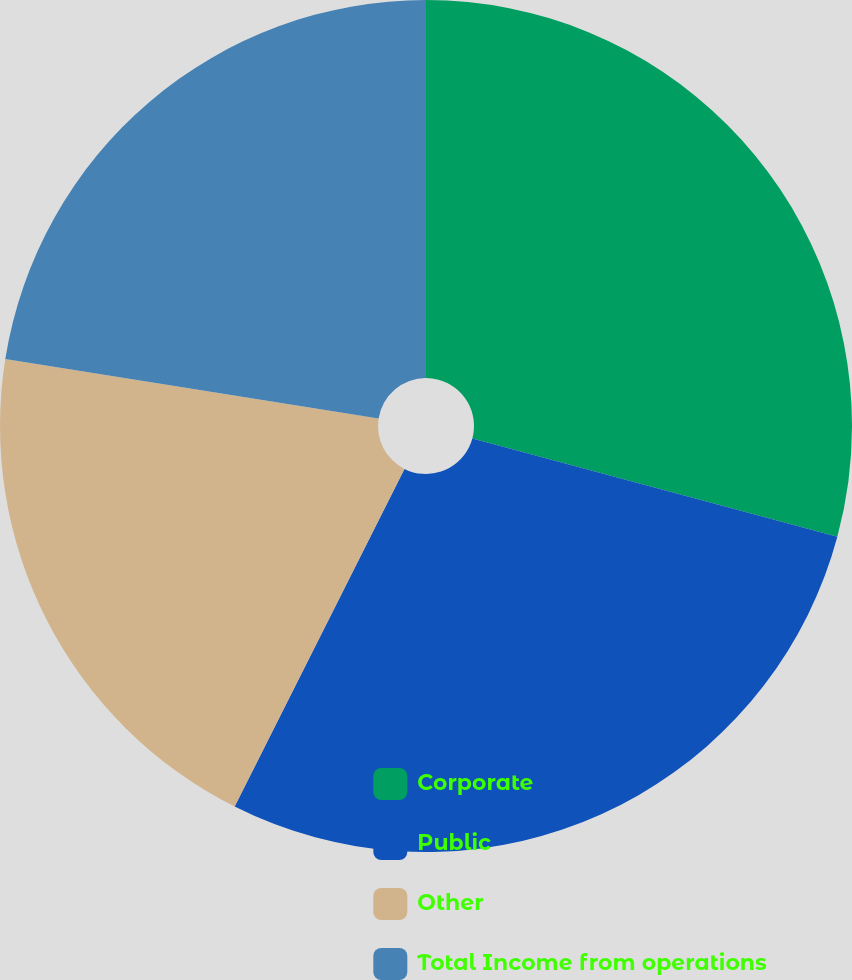Convert chart. <chart><loc_0><loc_0><loc_500><loc_500><pie_chart><fcel>Corporate<fcel>Public<fcel>Other<fcel>Total Income from operations<nl><fcel>29.19%<fcel>28.23%<fcel>20.1%<fcel>22.49%<nl></chart> 